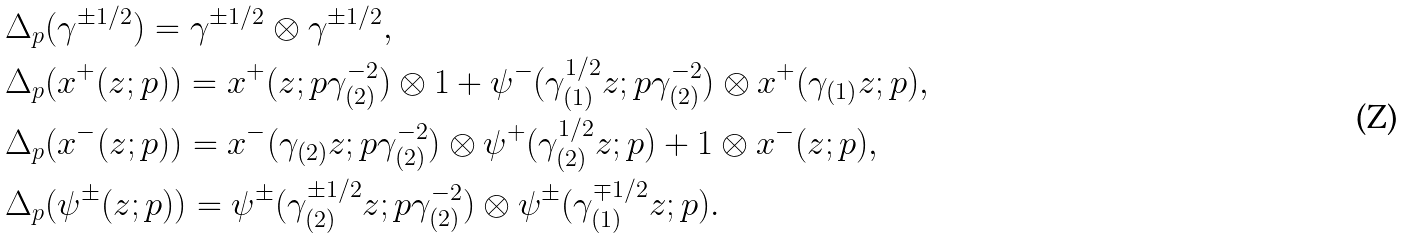Convert formula to latex. <formula><loc_0><loc_0><loc_500><loc_500>& \Delta _ { p } ( \gamma ^ { \pm 1 / 2 } ) = \gamma ^ { \pm 1 / 2 } \otimes \gamma ^ { \pm 1 / 2 } , \\ & \Delta _ { p } ( x ^ { + } ( z ; p ) ) = x ^ { + } ( z ; p \gamma _ { ( 2 ) } ^ { - 2 } ) \otimes 1 + \psi ^ { - } ( \gamma _ { ( 1 ) } ^ { 1 / 2 } z ; p \gamma _ { ( 2 ) } ^ { - 2 } ) \otimes x ^ { + } ( \gamma _ { ( 1 ) } z ; p ) , \\ & \Delta _ { p } ( x ^ { - } ( z ; p ) ) = x ^ { - } ( \gamma _ { ( 2 ) } z ; p \gamma _ { ( 2 ) } ^ { - 2 } ) \otimes \psi ^ { + } ( \gamma _ { ( 2 ) } ^ { 1 / 2 } z ; p ) + 1 \otimes x ^ { - } ( z ; p ) , \\ & \Delta _ { p } ( \psi ^ { \pm } ( z ; p ) ) = \psi ^ { \pm } ( \gamma _ { ( 2 ) } ^ { \pm 1 / 2 } z ; p \gamma _ { ( 2 ) } ^ { - 2 } ) \otimes \psi ^ { \pm } ( \gamma _ { ( 1 ) } ^ { \mp 1 / 2 } z ; p ) .</formula> 